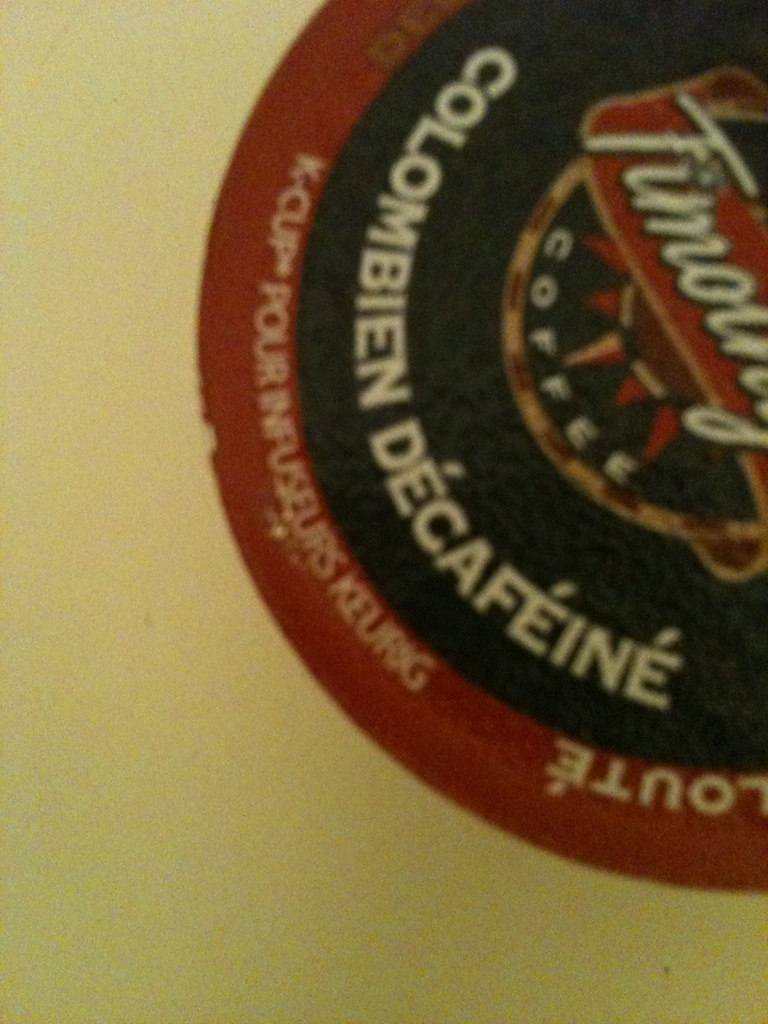If you were to design an ad campaign for this coffee, what would it look like? For this Colombian decaffeinated coffee, the ad campaign would focus on its high-quality origins and the care taken to produce it. The visual elements would include lush Colombian landscapes, farmers hand-picking coffee beans, and the meticulous decaffeination process. The tagline might be, 'Pure Flavor, No Compromise.' The ads would emphasize the rich, smooth taste and the health benefits of choosing decaffeinated coffee, targeting those who love coffee but prefer to avoid caffeine. 